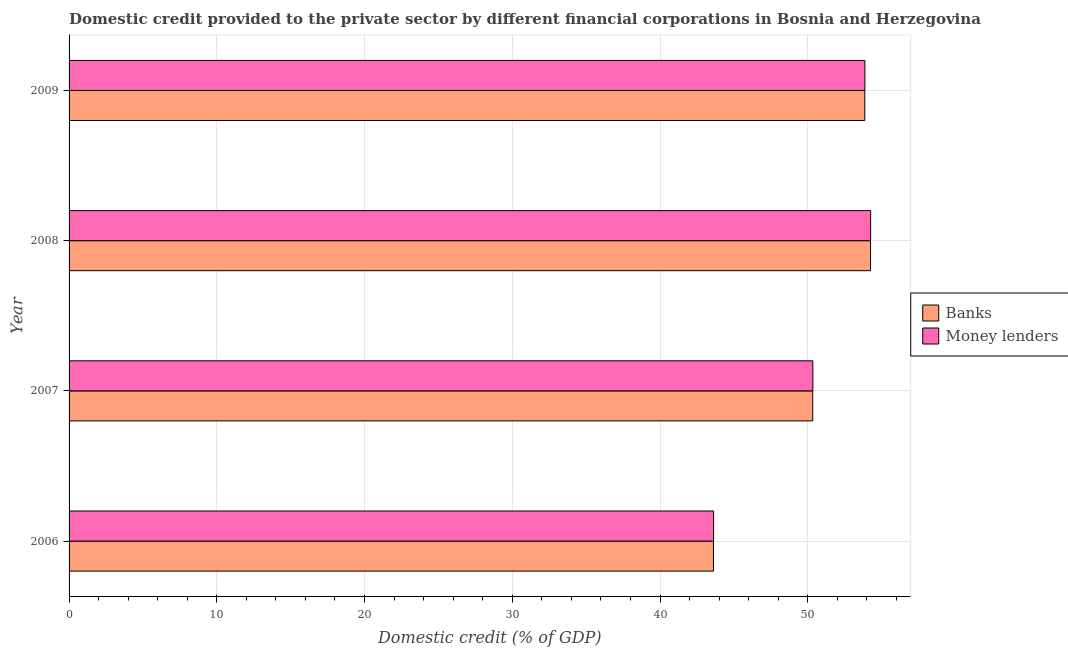How many groups of bars are there?
Give a very brief answer. 4. How many bars are there on the 3rd tick from the bottom?
Offer a very short reply. 2. What is the label of the 2nd group of bars from the top?
Give a very brief answer. 2008. What is the domestic credit provided by money lenders in 2008?
Your answer should be compact. 54.26. Across all years, what is the maximum domestic credit provided by money lenders?
Offer a very short reply. 54.26. Across all years, what is the minimum domestic credit provided by money lenders?
Your answer should be very brief. 43.63. What is the total domestic credit provided by money lenders in the graph?
Your answer should be very brief. 202.1. What is the difference between the domestic credit provided by banks in 2006 and that in 2008?
Give a very brief answer. -10.63. What is the difference between the domestic credit provided by banks in 2008 and the domestic credit provided by money lenders in 2007?
Your answer should be very brief. 3.91. What is the average domestic credit provided by banks per year?
Your response must be concise. 50.52. In the year 2006, what is the difference between the domestic credit provided by banks and domestic credit provided by money lenders?
Your response must be concise. -0.01. In how many years, is the domestic credit provided by banks greater than 36 %?
Your response must be concise. 4. What is the ratio of the domestic credit provided by banks in 2007 to that in 2009?
Your answer should be compact. 0.94. Is the difference between the domestic credit provided by banks in 2006 and 2009 greater than the difference between the domestic credit provided by money lenders in 2006 and 2009?
Keep it short and to the point. No. What is the difference between the highest and the second highest domestic credit provided by money lenders?
Make the answer very short. 0.39. What is the difference between the highest and the lowest domestic credit provided by banks?
Ensure brevity in your answer.  10.63. In how many years, is the domestic credit provided by banks greater than the average domestic credit provided by banks taken over all years?
Your response must be concise. 2. What does the 2nd bar from the top in 2006 represents?
Make the answer very short. Banks. What does the 1st bar from the bottom in 2006 represents?
Offer a very short reply. Banks. Are all the bars in the graph horizontal?
Give a very brief answer. Yes. How many years are there in the graph?
Offer a very short reply. 4. Does the graph contain any zero values?
Provide a short and direct response. No. Where does the legend appear in the graph?
Offer a very short reply. Center right. How are the legend labels stacked?
Offer a terse response. Vertical. What is the title of the graph?
Your response must be concise. Domestic credit provided to the private sector by different financial corporations in Bosnia and Herzegovina. What is the label or title of the X-axis?
Offer a very short reply. Domestic credit (% of GDP). What is the label or title of the Y-axis?
Provide a short and direct response. Year. What is the Domestic credit (% of GDP) in Banks in 2006?
Your response must be concise. 43.62. What is the Domestic credit (% of GDP) of Money lenders in 2006?
Offer a very short reply. 43.63. What is the Domestic credit (% of GDP) of Banks in 2007?
Offer a terse response. 50.34. What is the Domestic credit (% of GDP) of Money lenders in 2007?
Offer a terse response. 50.35. What is the Domestic credit (% of GDP) in Banks in 2008?
Your answer should be compact. 54.25. What is the Domestic credit (% of GDP) in Money lenders in 2008?
Provide a succinct answer. 54.26. What is the Domestic credit (% of GDP) in Banks in 2009?
Provide a succinct answer. 53.86. What is the Domestic credit (% of GDP) of Money lenders in 2009?
Your response must be concise. 53.87. Across all years, what is the maximum Domestic credit (% of GDP) of Banks?
Your response must be concise. 54.25. Across all years, what is the maximum Domestic credit (% of GDP) in Money lenders?
Make the answer very short. 54.26. Across all years, what is the minimum Domestic credit (% of GDP) in Banks?
Provide a short and direct response. 43.62. Across all years, what is the minimum Domestic credit (% of GDP) of Money lenders?
Offer a terse response. 43.63. What is the total Domestic credit (% of GDP) of Banks in the graph?
Give a very brief answer. 202.07. What is the total Domestic credit (% of GDP) in Money lenders in the graph?
Give a very brief answer. 202.1. What is the difference between the Domestic credit (% of GDP) of Banks in 2006 and that in 2007?
Your answer should be very brief. -6.72. What is the difference between the Domestic credit (% of GDP) of Money lenders in 2006 and that in 2007?
Provide a succinct answer. -6.72. What is the difference between the Domestic credit (% of GDP) of Banks in 2006 and that in 2008?
Offer a terse response. -10.63. What is the difference between the Domestic credit (% of GDP) of Money lenders in 2006 and that in 2008?
Your answer should be very brief. -10.63. What is the difference between the Domestic credit (% of GDP) in Banks in 2006 and that in 2009?
Ensure brevity in your answer.  -10.24. What is the difference between the Domestic credit (% of GDP) of Money lenders in 2006 and that in 2009?
Give a very brief answer. -10.24. What is the difference between the Domestic credit (% of GDP) in Banks in 2007 and that in 2008?
Keep it short and to the point. -3.91. What is the difference between the Domestic credit (% of GDP) of Money lenders in 2007 and that in 2008?
Your answer should be very brief. -3.91. What is the difference between the Domestic credit (% of GDP) in Banks in 2007 and that in 2009?
Provide a succinct answer. -3.52. What is the difference between the Domestic credit (% of GDP) in Money lenders in 2007 and that in 2009?
Your answer should be very brief. -3.52. What is the difference between the Domestic credit (% of GDP) in Banks in 2008 and that in 2009?
Make the answer very short. 0.39. What is the difference between the Domestic credit (% of GDP) of Money lenders in 2008 and that in 2009?
Give a very brief answer. 0.39. What is the difference between the Domestic credit (% of GDP) of Banks in 2006 and the Domestic credit (% of GDP) of Money lenders in 2007?
Provide a succinct answer. -6.73. What is the difference between the Domestic credit (% of GDP) in Banks in 2006 and the Domestic credit (% of GDP) in Money lenders in 2008?
Give a very brief answer. -10.64. What is the difference between the Domestic credit (% of GDP) of Banks in 2006 and the Domestic credit (% of GDP) of Money lenders in 2009?
Offer a terse response. -10.25. What is the difference between the Domestic credit (% of GDP) in Banks in 2007 and the Domestic credit (% of GDP) in Money lenders in 2008?
Keep it short and to the point. -3.92. What is the difference between the Domestic credit (% of GDP) in Banks in 2007 and the Domestic credit (% of GDP) in Money lenders in 2009?
Provide a succinct answer. -3.53. What is the difference between the Domestic credit (% of GDP) in Banks in 2008 and the Domestic credit (% of GDP) in Money lenders in 2009?
Ensure brevity in your answer.  0.38. What is the average Domestic credit (% of GDP) in Banks per year?
Ensure brevity in your answer.  50.52. What is the average Domestic credit (% of GDP) of Money lenders per year?
Make the answer very short. 50.53. In the year 2006, what is the difference between the Domestic credit (% of GDP) of Banks and Domestic credit (% of GDP) of Money lenders?
Your response must be concise. -0.01. In the year 2007, what is the difference between the Domestic credit (% of GDP) of Banks and Domestic credit (% of GDP) of Money lenders?
Make the answer very short. -0.01. In the year 2008, what is the difference between the Domestic credit (% of GDP) of Banks and Domestic credit (% of GDP) of Money lenders?
Keep it short and to the point. -0.01. In the year 2009, what is the difference between the Domestic credit (% of GDP) in Banks and Domestic credit (% of GDP) in Money lenders?
Ensure brevity in your answer.  -0.01. What is the ratio of the Domestic credit (% of GDP) of Banks in 2006 to that in 2007?
Offer a terse response. 0.87. What is the ratio of the Domestic credit (% of GDP) in Money lenders in 2006 to that in 2007?
Your response must be concise. 0.87. What is the ratio of the Domestic credit (% of GDP) in Banks in 2006 to that in 2008?
Keep it short and to the point. 0.8. What is the ratio of the Domestic credit (% of GDP) of Money lenders in 2006 to that in 2008?
Provide a short and direct response. 0.8. What is the ratio of the Domestic credit (% of GDP) in Banks in 2006 to that in 2009?
Your answer should be compact. 0.81. What is the ratio of the Domestic credit (% of GDP) in Money lenders in 2006 to that in 2009?
Keep it short and to the point. 0.81. What is the ratio of the Domestic credit (% of GDP) of Banks in 2007 to that in 2008?
Make the answer very short. 0.93. What is the ratio of the Domestic credit (% of GDP) of Money lenders in 2007 to that in 2008?
Offer a terse response. 0.93. What is the ratio of the Domestic credit (% of GDP) in Banks in 2007 to that in 2009?
Give a very brief answer. 0.93. What is the ratio of the Domestic credit (% of GDP) of Money lenders in 2007 to that in 2009?
Offer a terse response. 0.93. What is the ratio of the Domestic credit (% of GDP) in Banks in 2008 to that in 2009?
Your response must be concise. 1.01. What is the ratio of the Domestic credit (% of GDP) in Money lenders in 2008 to that in 2009?
Your response must be concise. 1.01. What is the difference between the highest and the second highest Domestic credit (% of GDP) of Banks?
Provide a succinct answer. 0.39. What is the difference between the highest and the second highest Domestic credit (% of GDP) in Money lenders?
Keep it short and to the point. 0.39. What is the difference between the highest and the lowest Domestic credit (% of GDP) in Banks?
Provide a short and direct response. 10.63. What is the difference between the highest and the lowest Domestic credit (% of GDP) in Money lenders?
Keep it short and to the point. 10.63. 